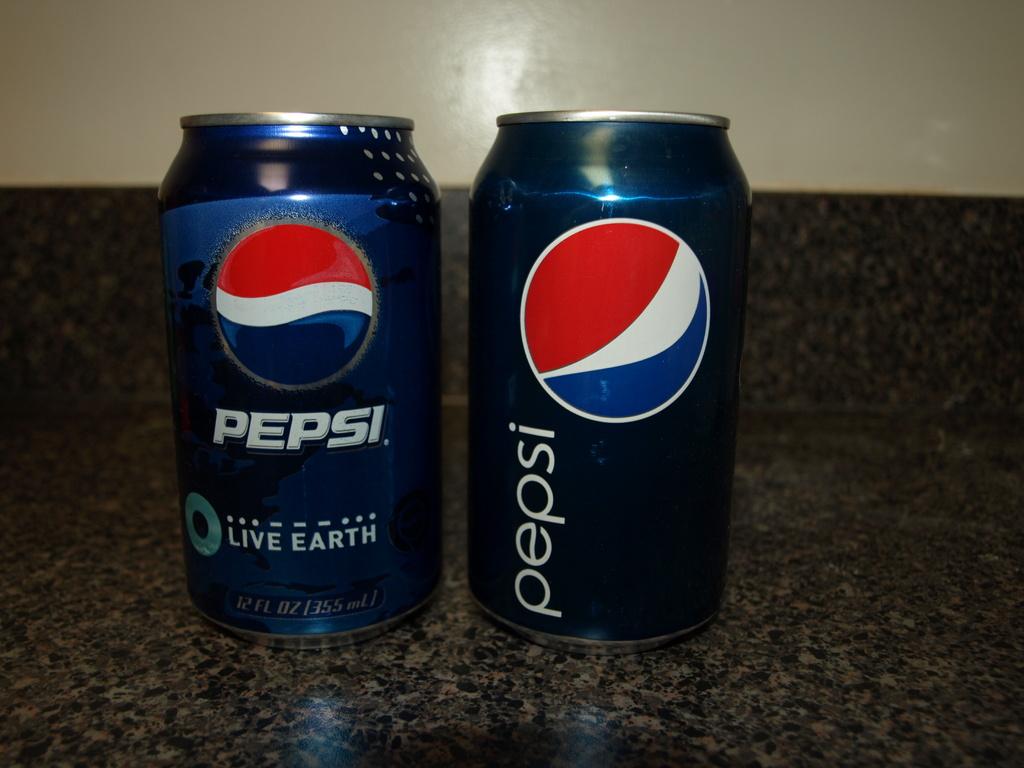What is the name of the soda?
Your answer should be very brief. Pepsi. 